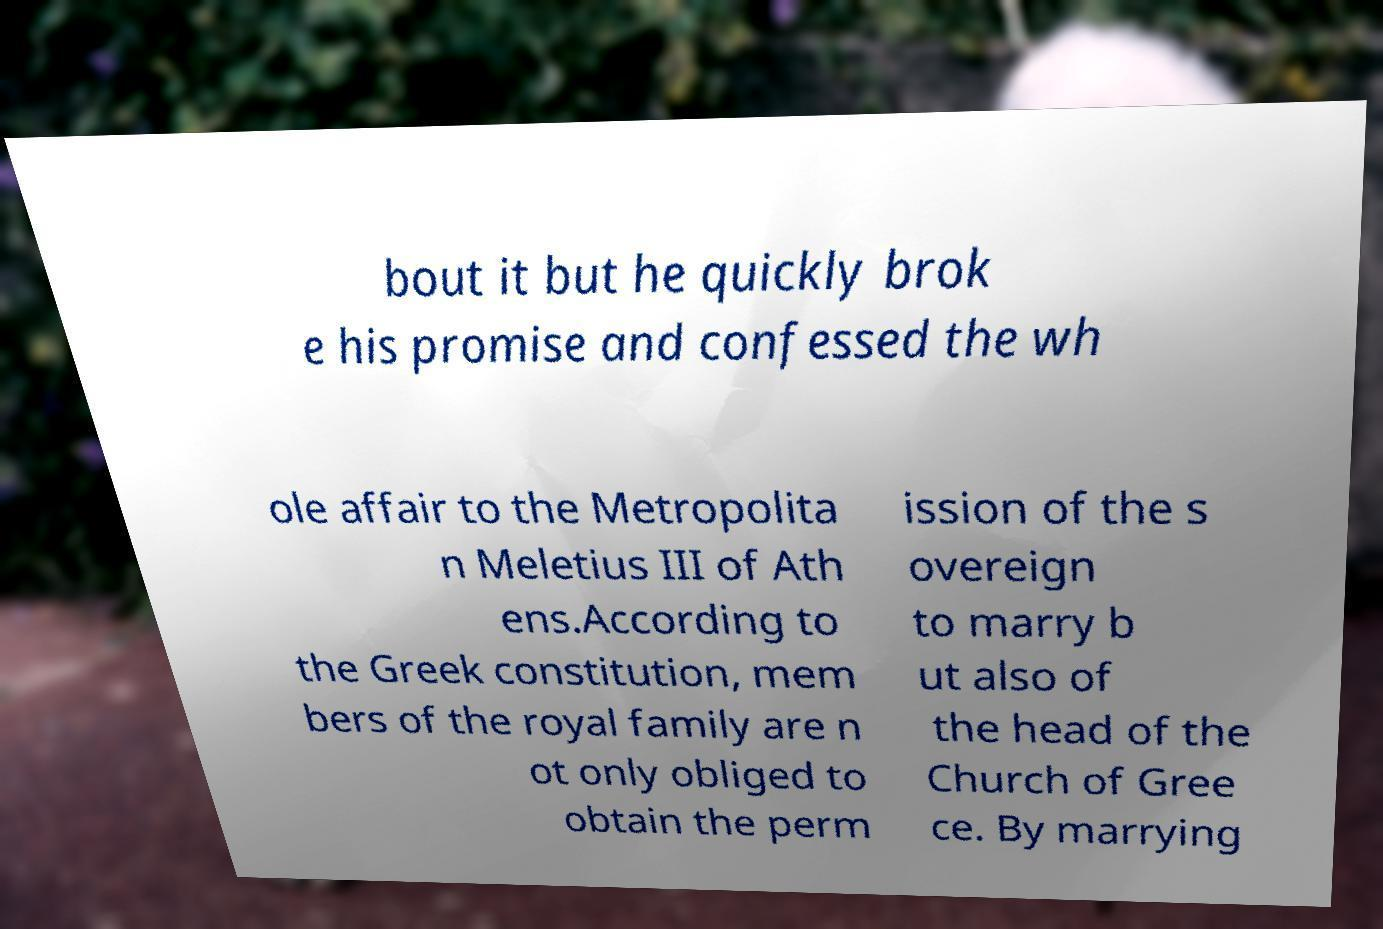I need the written content from this picture converted into text. Can you do that? bout it but he quickly brok e his promise and confessed the wh ole affair to the Metropolita n Meletius III of Ath ens.According to the Greek constitution, mem bers of the royal family are n ot only obliged to obtain the perm ission of the s overeign to marry b ut also of the head of the Church of Gree ce. By marrying 